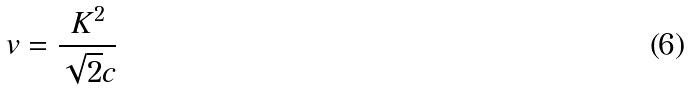<formula> <loc_0><loc_0><loc_500><loc_500>v = { \frac { K ^ { 2 } } { \sqrt { 2 } c } }</formula> 